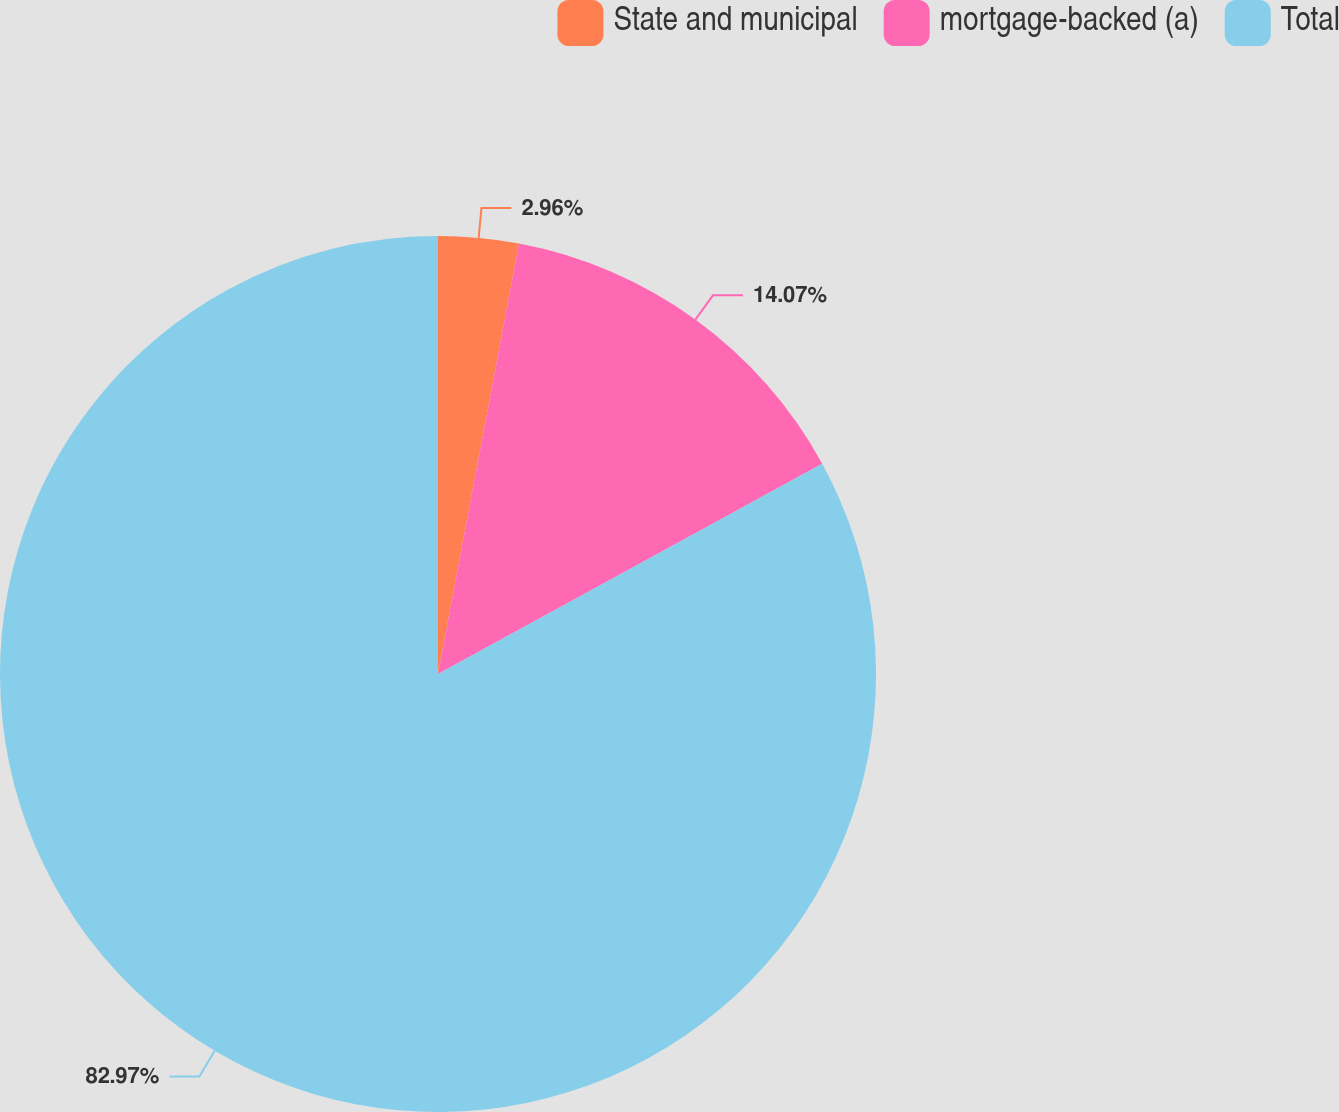Convert chart to OTSL. <chart><loc_0><loc_0><loc_500><loc_500><pie_chart><fcel>State and municipal<fcel>mortgage-backed (a)<fcel>Total<nl><fcel>2.96%<fcel>14.07%<fcel>82.97%<nl></chart> 